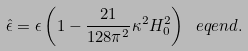<formula> <loc_0><loc_0><loc_500><loc_500>\hat { \epsilon } = \epsilon \left ( 1 - \frac { 2 1 } { 1 2 8 \pi ^ { 2 } } \kappa ^ { 2 } H _ { 0 } ^ { 2 } \right ) \ e q e n d { . }</formula> 